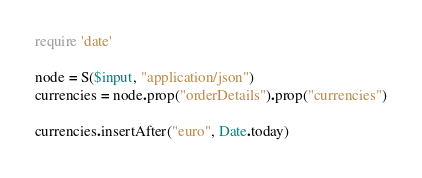Convert code to text. <code><loc_0><loc_0><loc_500><loc_500><_Ruby_>require 'date'

node = S($input, "application/json")
currencies = node.prop("orderDetails").prop("currencies")

currencies.insertAfter("euro", Date.today)
</code> 